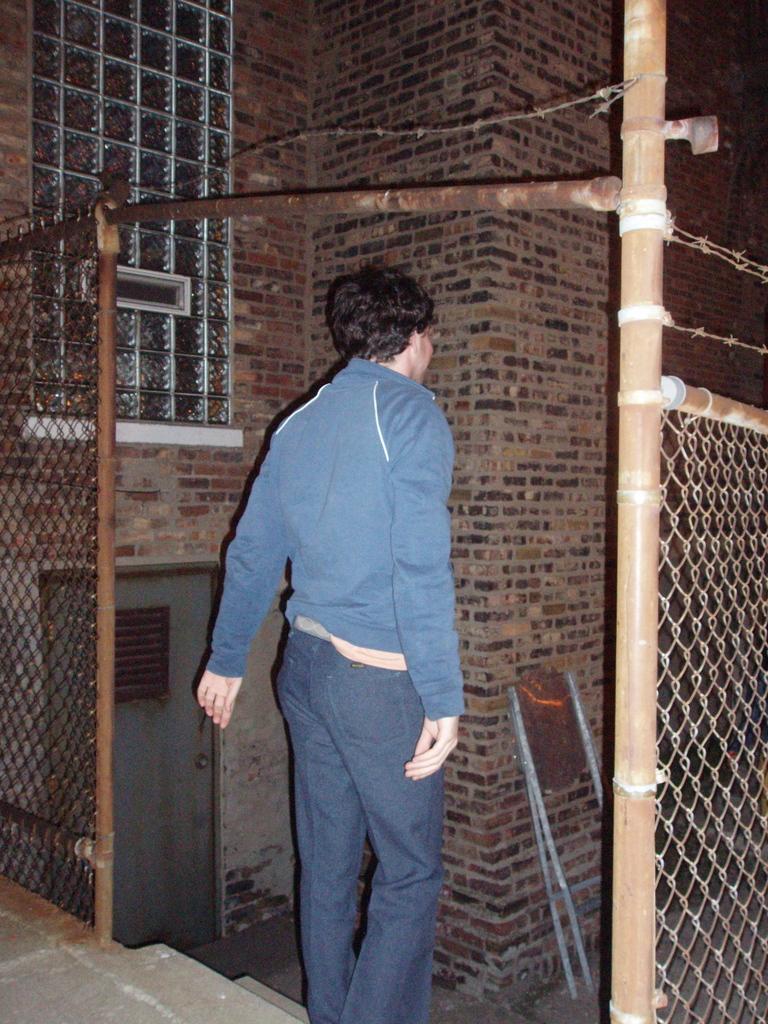Please provide a concise description of this image. The man in the middle of the picture wearing a blue jacket and blue jeans is standing on the staircase. Beside him, we see a fence. In front of him, we see a building which is made up of bricks. Beside him, we see a window. At the bottom of the picture, we see the staircase. This picture is clicked in the dark. 